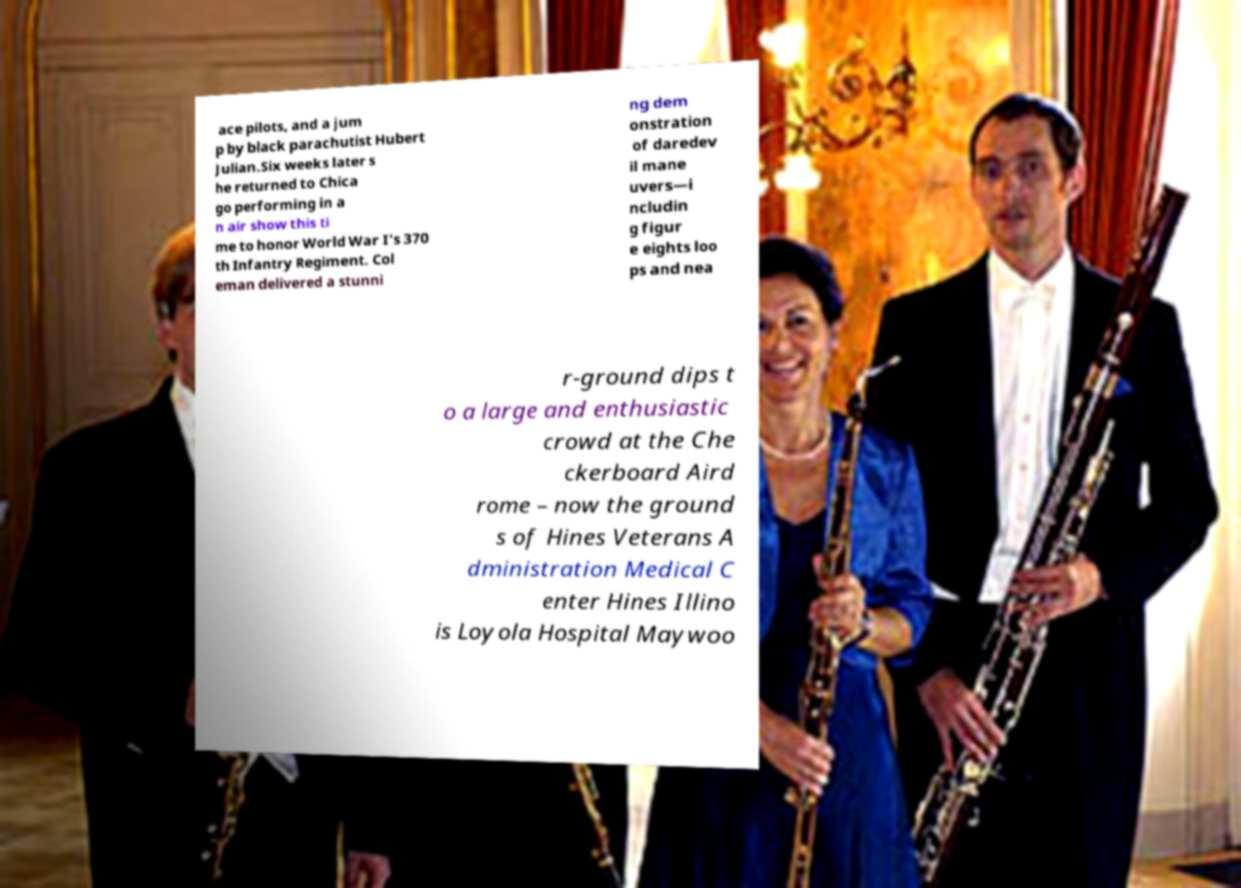There's text embedded in this image that I need extracted. Can you transcribe it verbatim? ace pilots, and a jum p by black parachutist Hubert Julian.Six weeks later s he returned to Chica go performing in a n air show this ti me to honor World War I's 370 th Infantry Regiment. Col eman delivered a stunni ng dem onstration of daredev il mane uvers—i ncludin g figur e eights loo ps and nea r-ground dips t o a large and enthusiastic crowd at the Che ckerboard Aird rome – now the ground s of Hines Veterans A dministration Medical C enter Hines Illino is Loyola Hospital Maywoo 